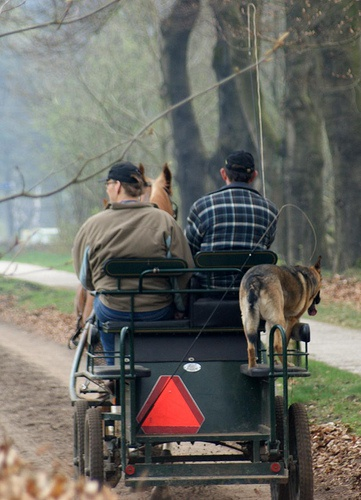Describe the objects in this image and their specific colors. I can see car in gray, black, purple, and darkblue tones, people in gray, black, and darkgray tones, people in gray, black, navy, and blue tones, dog in gray, black, and tan tones, and horse in gray, tan, and black tones in this image. 